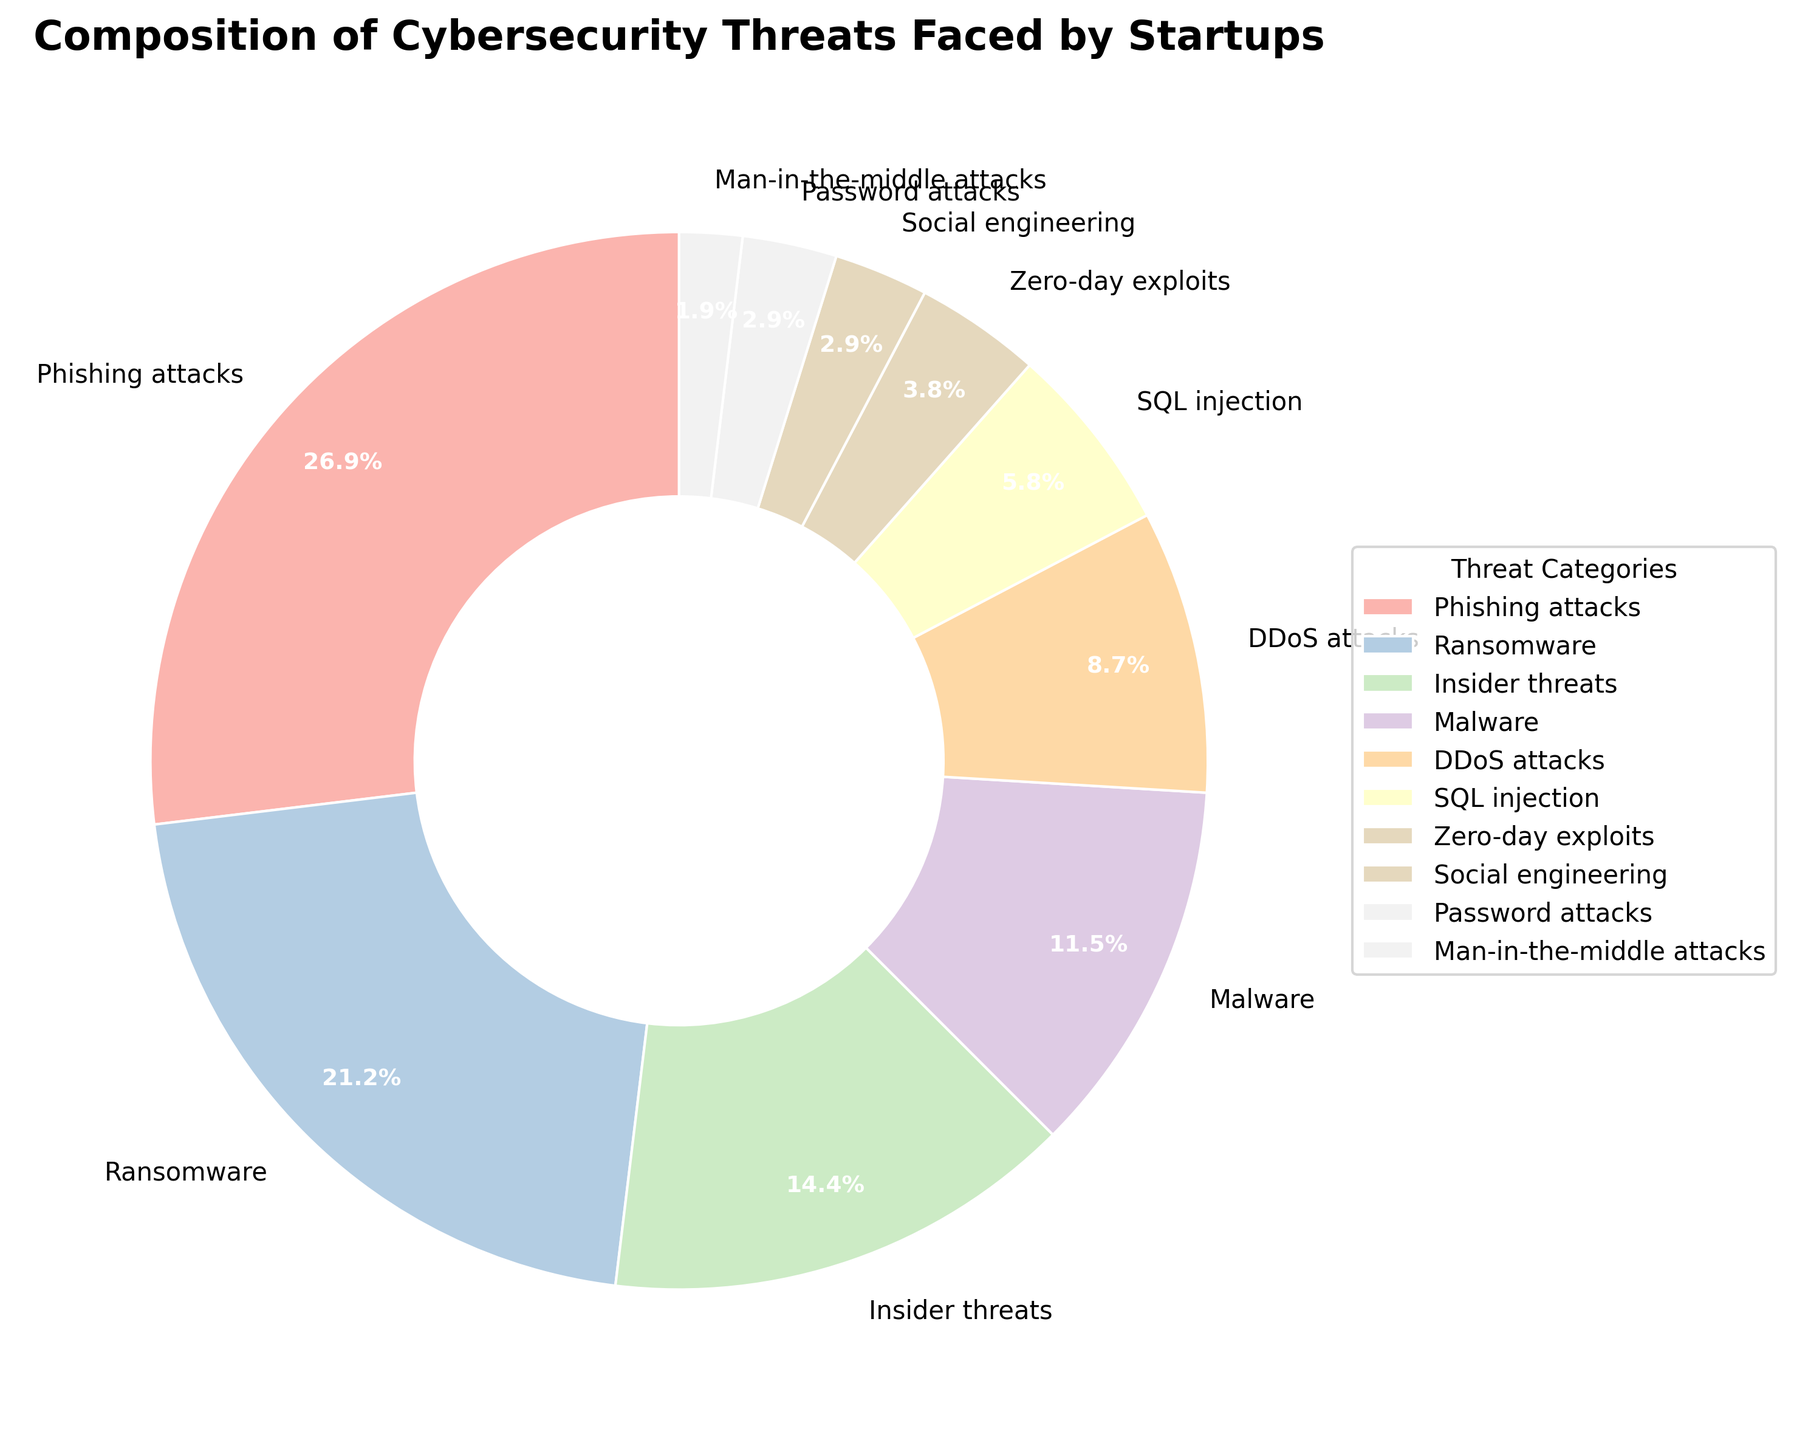what is the most common cybersecurity threat faced by startups? The largest slice of the pie chart corresponds to phishing attacks, indicating it has the highest percentage.
Answer: Phishing attacks What percentage of threats are due to insider threats and malware combined? Add the percentage values for insider threats and malware. Insider threats are 15% and malware is 12%. The sum is 15% + 12% = 27%.
Answer: 27% Which is more prevalent, DDoS attacks or SQL injection? Compare the percentage values of DDoS attacks (9%) and SQL injection (6%). Since 9% is greater than 6%, DDoS attacks are more prevalent.
Answer: DDoS attacks How many categories contribute less than 5% each to the total threats? Identify the slices with percentages less than 5%. These categories are zero-day exploits (4%), social engineering (3%), password attacks (3%), and man-in-the-middle attacks (2%). There are 4 such categories.
Answer: 4 Are phishing attacks more than double the percentage of ransomware attacks? Compare the percentage of phishing attacks (28%) to double the percentage of ransomware attacks (2 * 22% = 44%). Since 28% is not more than 44%, phishing attacks are not more than double.
Answer: No What is the visual attribute difference between the highest and lowest threat categories in the pie chart? The highest threat category (phishing attacks) has the largest pie slice, while the lowest (man-in-the-middle attacks) has the smallest slice. The visual attribute difference is the size of these slices, with phishing being significantly larger.
Answer: Slice size Which category is represented by the lightest colored slice in the pie chart? The slice for social engineering appears to be the lightest in color, indicating it is visually distinct.
Answer: Social engineering If you combine the percentages of social engineering and password attacks, is the resulting percentage greater or less than the percentage for insider threats? Add the percentages for social engineering (3%) and password attacks (3%) to get 6%, which is less than the percentage for insider threats (15%).
Answer: Less Which categories have the smallest equal percentage and what is that percentage? Both password attacks and social engineering are represented with a percentage of 3%, making them the smallest equal percentages in the chart.
Answer: Password attacks and social engineering, 3% Is the percentage of ransomware attacks closer to the percentage for phishing attacks or insider threats? Compare the differences: Ransomware (22%) to phishing attacks (28%) gives a difference of 6%, while ransomware (22%) to insider threats (15%) gives a difference of 7%. The percentage difference from phishing attacks (6%) is smaller.
Answer: Phishing attacks 